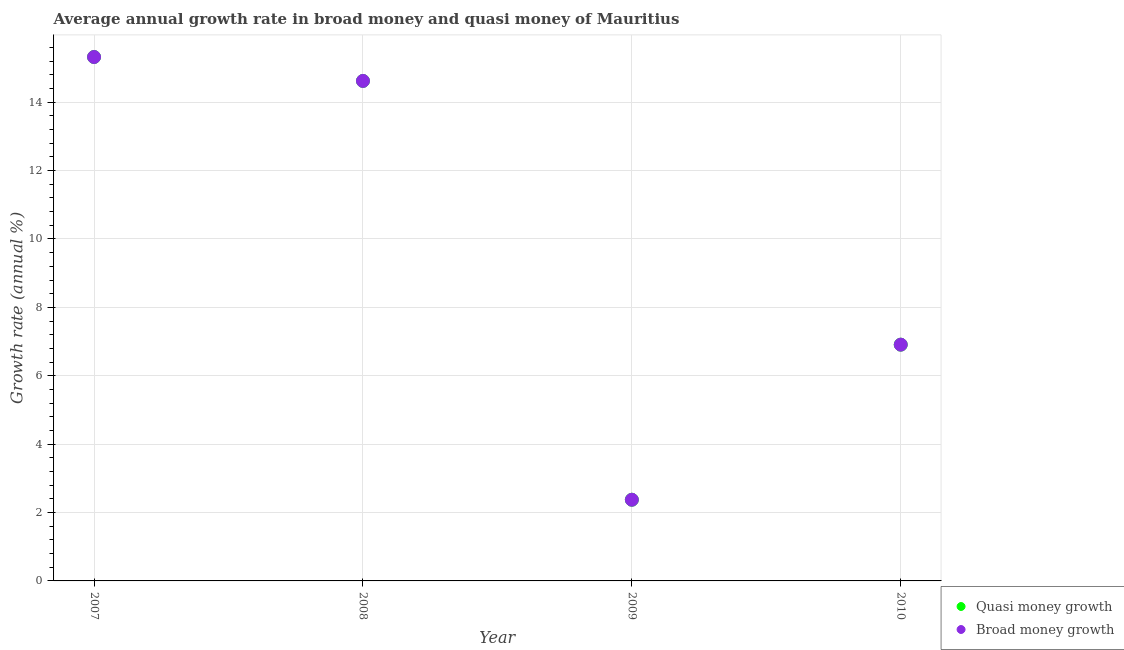Is the number of dotlines equal to the number of legend labels?
Your answer should be compact. Yes. What is the annual growth rate in quasi money in 2010?
Your answer should be compact. 6.91. Across all years, what is the maximum annual growth rate in quasi money?
Give a very brief answer. 15.32. Across all years, what is the minimum annual growth rate in quasi money?
Keep it short and to the point. 2.37. In which year was the annual growth rate in quasi money minimum?
Ensure brevity in your answer.  2009. What is the total annual growth rate in broad money in the graph?
Make the answer very short. 39.23. What is the difference between the annual growth rate in broad money in 2009 and that in 2010?
Provide a succinct answer. -4.54. What is the difference between the annual growth rate in broad money in 2007 and the annual growth rate in quasi money in 2010?
Offer a terse response. 8.41. What is the average annual growth rate in quasi money per year?
Provide a short and direct response. 9.81. In how many years, is the annual growth rate in quasi money greater than 14.8 %?
Offer a terse response. 1. What is the ratio of the annual growth rate in quasi money in 2007 to that in 2010?
Provide a succinct answer. 2.22. Is the annual growth rate in broad money in 2007 less than that in 2010?
Ensure brevity in your answer.  No. Is the difference between the annual growth rate in quasi money in 2008 and 2010 greater than the difference between the annual growth rate in broad money in 2008 and 2010?
Make the answer very short. No. What is the difference between the highest and the second highest annual growth rate in quasi money?
Offer a very short reply. 0.7. What is the difference between the highest and the lowest annual growth rate in broad money?
Provide a succinct answer. 12.95. Does the annual growth rate in quasi money monotonically increase over the years?
Offer a terse response. No. Is the annual growth rate in quasi money strictly less than the annual growth rate in broad money over the years?
Your answer should be compact. No. How many dotlines are there?
Give a very brief answer. 2. What is the difference between two consecutive major ticks on the Y-axis?
Keep it short and to the point. 2. Does the graph contain any zero values?
Your answer should be compact. No. Does the graph contain grids?
Provide a short and direct response. Yes. How many legend labels are there?
Provide a short and direct response. 2. How are the legend labels stacked?
Your answer should be very brief. Vertical. What is the title of the graph?
Give a very brief answer. Average annual growth rate in broad money and quasi money of Mauritius. What is the label or title of the X-axis?
Your response must be concise. Year. What is the label or title of the Y-axis?
Provide a short and direct response. Growth rate (annual %). What is the Growth rate (annual %) of Quasi money growth in 2007?
Offer a terse response. 15.32. What is the Growth rate (annual %) of Broad money growth in 2007?
Keep it short and to the point. 15.32. What is the Growth rate (annual %) of Quasi money growth in 2008?
Your response must be concise. 14.62. What is the Growth rate (annual %) in Broad money growth in 2008?
Provide a succinct answer. 14.62. What is the Growth rate (annual %) in Quasi money growth in 2009?
Your response must be concise. 2.37. What is the Growth rate (annual %) of Broad money growth in 2009?
Provide a short and direct response. 2.37. What is the Growth rate (annual %) of Quasi money growth in 2010?
Provide a short and direct response. 6.91. What is the Growth rate (annual %) in Broad money growth in 2010?
Offer a terse response. 6.91. Across all years, what is the maximum Growth rate (annual %) of Quasi money growth?
Provide a succinct answer. 15.32. Across all years, what is the maximum Growth rate (annual %) in Broad money growth?
Ensure brevity in your answer.  15.32. Across all years, what is the minimum Growth rate (annual %) of Quasi money growth?
Provide a short and direct response. 2.37. Across all years, what is the minimum Growth rate (annual %) in Broad money growth?
Offer a terse response. 2.37. What is the total Growth rate (annual %) of Quasi money growth in the graph?
Your answer should be compact. 39.23. What is the total Growth rate (annual %) of Broad money growth in the graph?
Your answer should be very brief. 39.23. What is the difference between the Growth rate (annual %) of Quasi money growth in 2007 and that in 2008?
Provide a succinct answer. 0.7. What is the difference between the Growth rate (annual %) in Broad money growth in 2007 and that in 2008?
Your answer should be compact. 0.7. What is the difference between the Growth rate (annual %) in Quasi money growth in 2007 and that in 2009?
Provide a succinct answer. 12.95. What is the difference between the Growth rate (annual %) of Broad money growth in 2007 and that in 2009?
Give a very brief answer. 12.95. What is the difference between the Growth rate (annual %) of Quasi money growth in 2007 and that in 2010?
Keep it short and to the point. 8.41. What is the difference between the Growth rate (annual %) in Broad money growth in 2007 and that in 2010?
Your response must be concise. 8.41. What is the difference between the Growth rate (annual %) in Quasi money growth in 2008 and that in 2009?
Keep it short and to the point. 12.25. What is the difference between the Growth rate (annual %) in Broad money growth in 2008 and that in 2009?
Offer a terse response. 12.25. What is the difference between the Growth rate (annual %) in Quasi money growth in 2008 and that in 2010?
Provide a succinct answer. 7.71. What is the difference between the Growth rate (annual %) in Broad money growth in 2008 and that in 2010?
Your answer should be compact. 7.71. What is the difference between the Growth rate (annual %) in Quasi money growth in 2009 and that in 2010?
Provide a short and direct response. -4.54. What is the difference between the Growth rate (annual %) of Broad money growth in 2009 and that in 2010?
Offer a very short reply. -4.54. What is the difference between the Growth rate (annual %) of Quasi money growth in 2007 and the Growth rate (annual %) of Broad money growth in 2008?
Offer a terse response. 0.7. What is the difference between the Growth rate (annual %) of Quasi money growth in 2007 and the Growth rate (annual %) of Broad money growth in 2009?
Provide a short and direct response. 12.95. What is the difference between the Growth rate (annual %) in Quasi money growth in 2007 and the Growth rate (annual %) in Broad money growth in 2010?
Provide a succinct answer. 8.41. What is the difference between the Growth rate (annual %) in Quasi money growth in 2008 and the Growth rate (annual %) in Broad money growth in 2009?
Your response must be concise. 12.25. What is the difference between the Growth rate (annual %) of Quasi money growth in 2008 and the Growth rate (annual %) of Broad money growth in 2010?
Ensure brevity in your answer.  7.71. What is the difference between the Growth rate (annual %) of Quasi money growth in 2009 and the Growth rate (annual %) of Broad money growth in 2010?
Your answer should be very brief. -4.54. What is the average Growth rate (annual %) of Quasi money growth per year?
Keep it short and to the point. 9.81. What is the average Growth rate (annual %) of Broad money growth per year?
Make the answer very short. 9.81. In the year 2007, what is the difference between the Growth rate (annual %) in Quasi money growth and Growth rate (annual %) in Broad money growth?
Offer a terse response. 0. In the year 2008, what is the difference between the Growth rate (annual %) in Quasi money growth and Growth rate (annual %) in Broad money growth?
Make the answer very short. 0. In the year 2009, what is the difference between the Growth rate (annual %) in Quasi money growth and Growth rate (annual %) in Broad money growth?
Your answer should be very brief. 0. What is the ratio of the Growth rate (annual %) of Quasi money growth in 2007 to that in 2008?
Offer a terse response. 1.05. What is the ratio of the Growth rate (annual %) of Broad money growth in 2007 to that in 2008?
Your response must be concise. 1.05. What is the ratio of the Growth rate (annual %) of Quasi money growth in 2007 to that in 2009?
Your answer should be compact. 6.45. What is the ratio of the Growth rate (annual %) of Broad money growth in 2007 to that in 2009?
Your answer should be very brief. 6.45. What is the ratio of the Growth rate (annual %) of Quasi money growth in 2007 to that in 2010?
Keep it short and to the point. 2.22. What is the ratio of the Growth rate (annual %) of Broad money growth in 2007 to that in 2010?
Your response must be concise. 2.22. What is the ratio of the Growth rate (annual %) of Quasi money growth in 2008 to that in 2009?
Provide a succinct answer. 6.16. What is the ratio of the Growth rate (annual %) of Broad money growth in 2008 to that in 2009?
Your answer should be compact. 6.16. What is the ratio of the Growth rate (annual %) in Quasi money growth in 2008 to that in 2010?
Offer a very short reply. 2.12. What is the ratio of the Growth rate (annual %) in Broad money growth in 2008 to that in 2010?
Ensure brevity in your answer.  2.12. What is the ratio of the Growth rate (annual %) of Quasi money growth in 2009 to that in 2010?
Keep it short and to the point. 0.34. What is the ratio of the Growth rate (annual %) of Broad money growth in 2009 to that in 2010?
Your response must be concise. 0.34. What is the difference between the highest and the second highest Growth rate (annual %) of Quasi money growth?
Provide a succinct answer. 0.7. What is the difference between the highest and the second highest Growth rate (annual %) in Broad money growth?
Make the answer very short. 0.7. What is the difference between the highest and the lowest Growth rate (annual %) of Quasi money growth?
Offer a terse response. 12.95. What is the difference between the highest and the lowest Growth rate (annual %) of Broad money growth?
Your answer should be very brief. 12.95. 